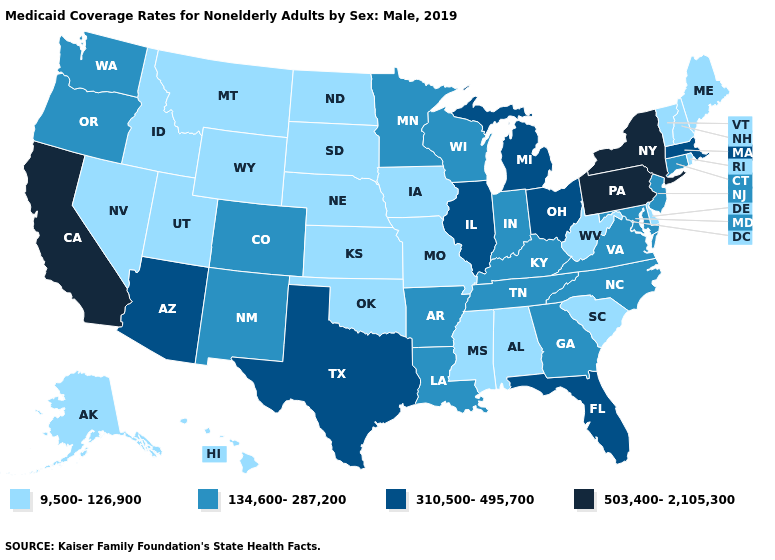What is the highest value in states that border Tennessee?
Concise answer only. 134,600-287,200. Name the states that have a value in the range 9,500-126,900?
Short answer required. Alabama, Alaska, Delaware, Hawaii, Idaho, Iowa, Kansas, Maine, Mississippi, Missouri, Montana, Nebraska, Nevada, New Hampshire, North Dakota, Oklahoma, Rhode Island, South Carolina, South Dakota, Utah, Vermont, West Virginia, Wyoming. Name the states that have a value in the range 503,400-2,105,300?
Keep it brief. California, New York, Pennsylvania. Which states hav the highest value in the Northeast?
Give a very brief answer. New York, Pennsylvania. What is the highest value in the USA?
Keep it brief. 503,400-2,105,300. Does the first symbol in the legend represent the smallest category?
Answer briefly. Yes. What is the value of Florida?
Give a very brief answer. 310,500-495,700. Is the legend a continuous bar?
Be succinct. No. What is the value of Nevada?
Quick response, please. 9,500-126,900. Is the legend a continuous bar?
Keep it brief. No. What is the lowest value in states that border Iowa?
Give a very brief answer. 9,500-126,900. Which states have the highest value in the USA?
Write a very short answer. California, New York, Pennsylvania. Does Wyoming have the lowest value in the USA?
Give a very brief answer. Yes. Is the legend a continuous bar?
Keep it brief. No. 